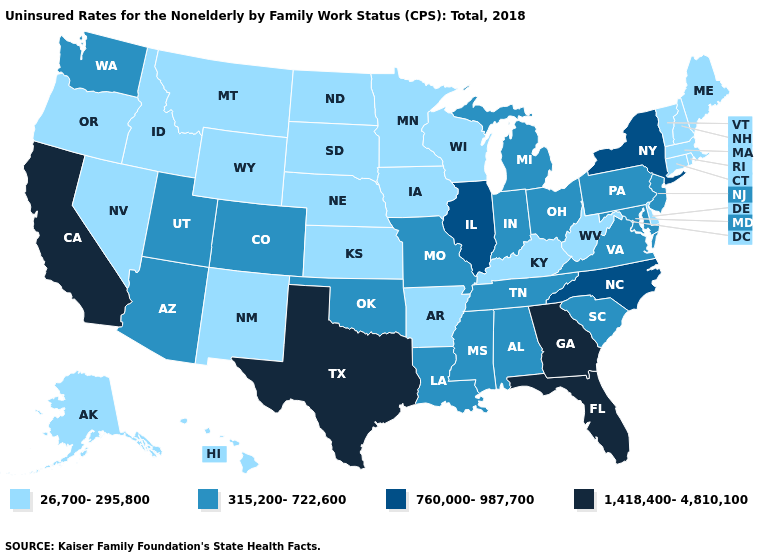Which states hav the highest value in the MidWest?
Short answer required. Illinois. What is the value of Delaware?
Write a very short answer. 26,700-295,800. Which states have the lowest value in the USA?
Write a very short answer. Alaska, Arkansas, Connecticut, Delaware, Hawaii, Idaho, Iowa, Kansas, Kentucky, Maine, Massachusetts, Minnesota, Montana, Nebraska, Nevada, New Hampshire, New Mexico, North Dakota, Oregon, Rhode Island, South Dakota, Vermont, West Virginia, Wisconsin, Wyoming. Name the states that have a value in the range 1,418,400-4,810,100?
Give a very brief answer. California, Florida, Georgia, Texas. What is the value of Hawaii?
Give a very brief answer. 26,700-295,800. Among the states that border Indiana , which have the highest value?
Give a very brief answer. Illinois. Does Pennsylvania have the lowest value in the USA?
Short answer required. No. Does Oklahoma have a lower value than Alaska?
Quick response, please. No. What is the value of Tennessee?
Short answer required. 315,200-722,600. Name the states that have a value in the range 315,200-722,600?
Keep it brief. Alabama, Arizona, Colorado, Indiana, Louisiana, Maryland, Michigan, Mississippi, Missouri, New Jersey, Ohio, Oklahoma, Pennsylvania, South Carolina, Tennessee, Utah, Virginia, Washington. What is the value of Montana?
Short answer required. 26,700-295,800. Name the states that have a value in the range 26,700-295,800?
Quick response, please. Alaska, Arkansas, Connecticut, Delaware, Hawaii, Idaho, Iowa, Kansas, Kentucky, Maine, Massachusetts, Minnesota, Montana, Nebraska, Nevada, New Hampshire, New Mexico, North Dakota, Oregon, Rhode Island, South Dakota, Vermont, West Virginia, Wisconsin, Wyoming. Name the states that have a value in the range 760,000-987,700?
Keep it brief. Illinois, New York, North Carolina. What is the lowest value in states that border Kansas?
Quick response, please. 26,700-295,800. 